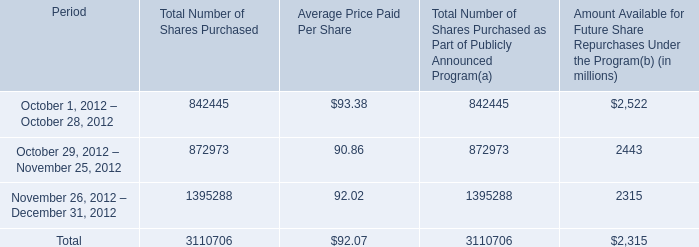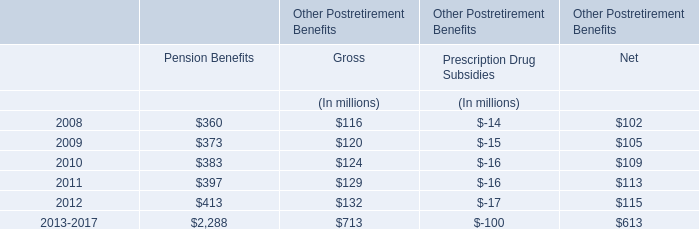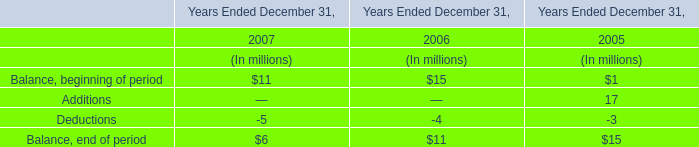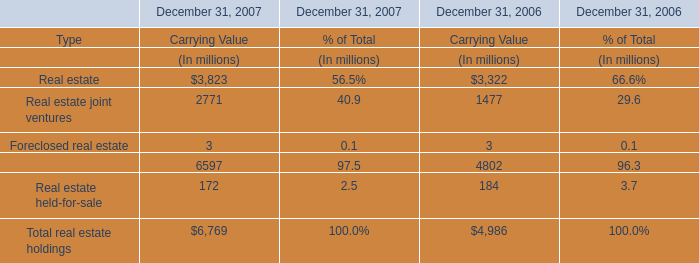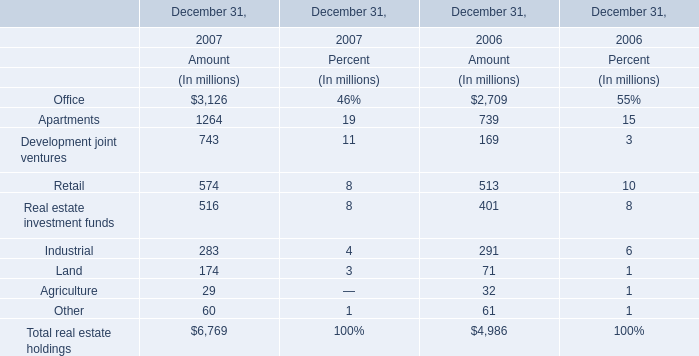Which element exceeds 10% of total for Amout in 2006? 
Answer: Office, Apartments, Retail. 